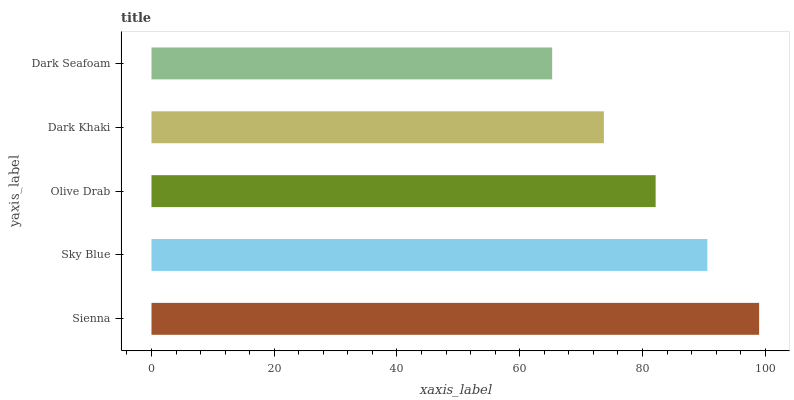Is Dark Seafoam the minimum?
Answer yes or no. Yes. Is Sienna the maximum?
Answer yes or no. Yes. Is Sky Blue the minimum?
Answer yes or no. No. Is Sky Blue the maximum?
Answer yes or no. No. Is Sienna greater than Sky Blue?
Answer yes or no. Yes. Is Sky Blue less than Sienna?
Answer yes or no. Yes. Is Sky Blue greater than Sienna?
Answer yes or no. No. Is Sienna less than Sky Blue?
Answer yes or no. No. Is Olive Drab the high median?
Answer yes or no. Yes. Is Olive Drab the low median?
Answer yes or no. Yes. Is Sienna the high median?
Answer yes or no. No. Is Dark Khaki the low median?
Answer yes or no. No. 